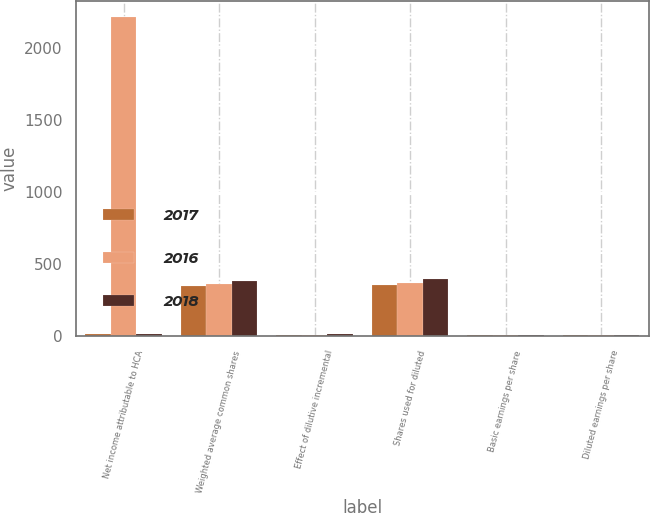Convert chart. <chart><loc_0><loc_0><loc_500><loc_500><stacked_bar_chart><ecel><fcel>Net income attributable to HCA<fcel>Weighted average common shares<fcel>Effect of dilutive incremental<fcel>Shares used for diluted<fcel>Basic earnings per share<fcel>Diluted earnings per share<nl><fcel>2017<fcel>11.58<fcel>347.3<fcel>8.01<fcel>355.3<fcel>10.9<fcel>10.66<nl><fcel>2016<fcel>2216<fcel>362.31<fcel>9.92<fcel>372.22<fcel>6.12<fcel>5.95<nl><fcel>2018<fcel>11.58<fcel>383.59<fcel>12.26<fcel>395.85<fcel>7.53<fcel>7.3<nl></chart> 